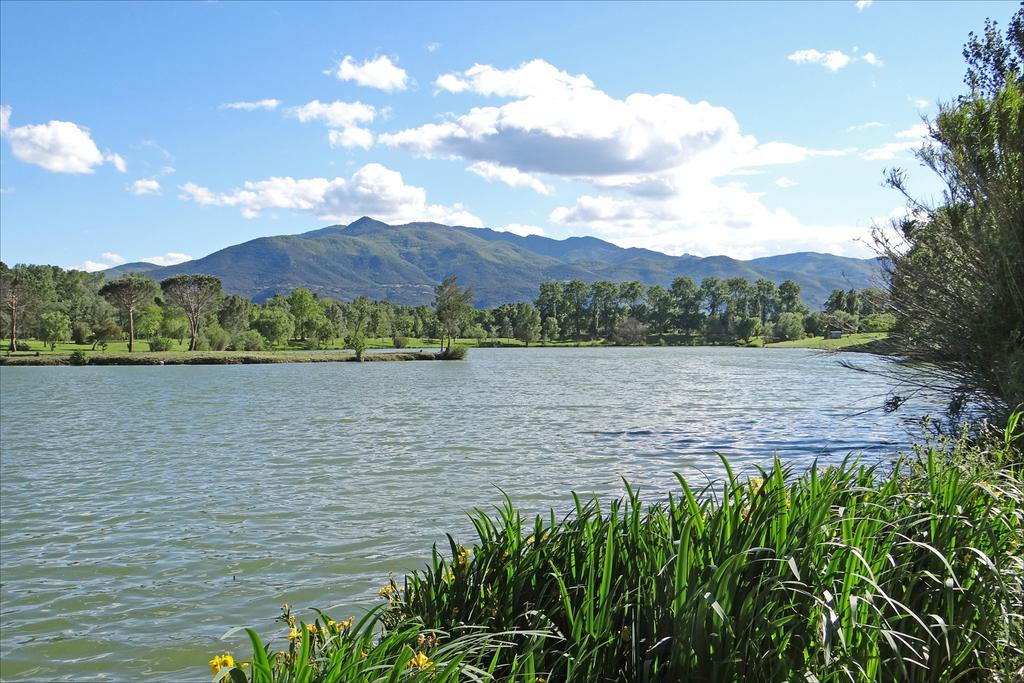What type of natural environment is depicted in the image? The image contains grass, water, trees, and hills, which are all elements of a natural environment. Can you describe the water in the image? The image shows water, but it doesn't provide any specific details about the water. What else can be seen in the image besides the natural elements? The sky is visible in the image. How would you describe the terrain in the image? The image shows hills, which suggests a hilly or mountainous terrain. What time of day is it in the image, and how does the hospital play a role in the scene? There is no hospital present in the image, and the time of day cannot be determined from the image alone. 